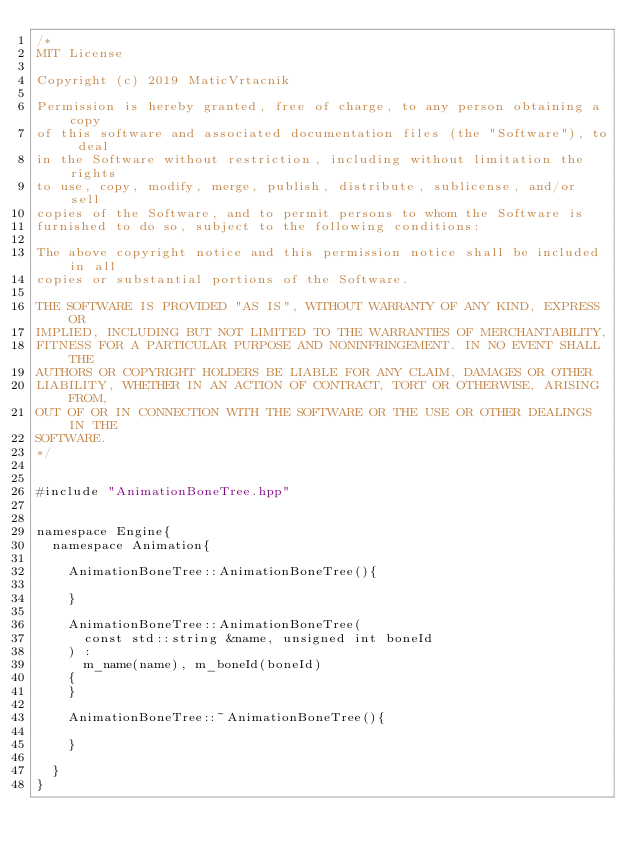Convert code to text. <code><loc_0><loc_0><loc_500><loc_500><_C++_>/*
MIT License

Copyright (c) 2019 MaticVrtacnik

Permission is hereby granted, free of charge, to any person obtaining a copy
of this software and associated documentation files (the "Software"), to deal
in the Software without restriction, including without limitation the rights
to use, copy, modify, merge, publish, distribute, sublicense, and/or sell
copies of the Software, and to permit persons to whom the Software is
furnished to do so, subject to the following conditions:

The above copyright notice and this permission notice shall be included in all
copies or substantial portions of the Software.

THE SOFTWARE IS PROVIDED "AS IS", WITHOUT WARRANTY OF ANY KIND, EXPRESS OR
IMPLIED, INCLUDING BUT NOT LIMITED TO THE WARRANTIES OF MERCHANTABILITY,
FITNESS FOR A PARTICULAR PURPOSE AND NONINFRINGEMENT. IN NO EVENT SHALL THE
AUTHORS OR COPYRIGHT HOLDERS BE LIABLE FOR ANY CLAIM, DAMAGES OR OTHER
LIABILITY, WHETHER IN AN ACTION OF CONTRACT, TORT OR OTHERWISE, ARISING FROM,
OUT OF OR IN CONNECTION WITH THE SOFTWARE OR THE USE OR OTHER DEALINGS IN THE
SOFTWARE.
*/


#include "AnimationBoneTree.hpp"


namespace Engine{
	namespace Animation{

		AnimationBoneTree::AnimationBoneTree(){

		}

		AnimationBoneTree::AnimationBoneTree(
			const std::string &name, unsigned int boneId
		) :
			m_name(name), m_boneId(boneId)
		{
		}

		AnimationBoneTree::~AnimationBoneTree(){

		}

	}
}
</code> 